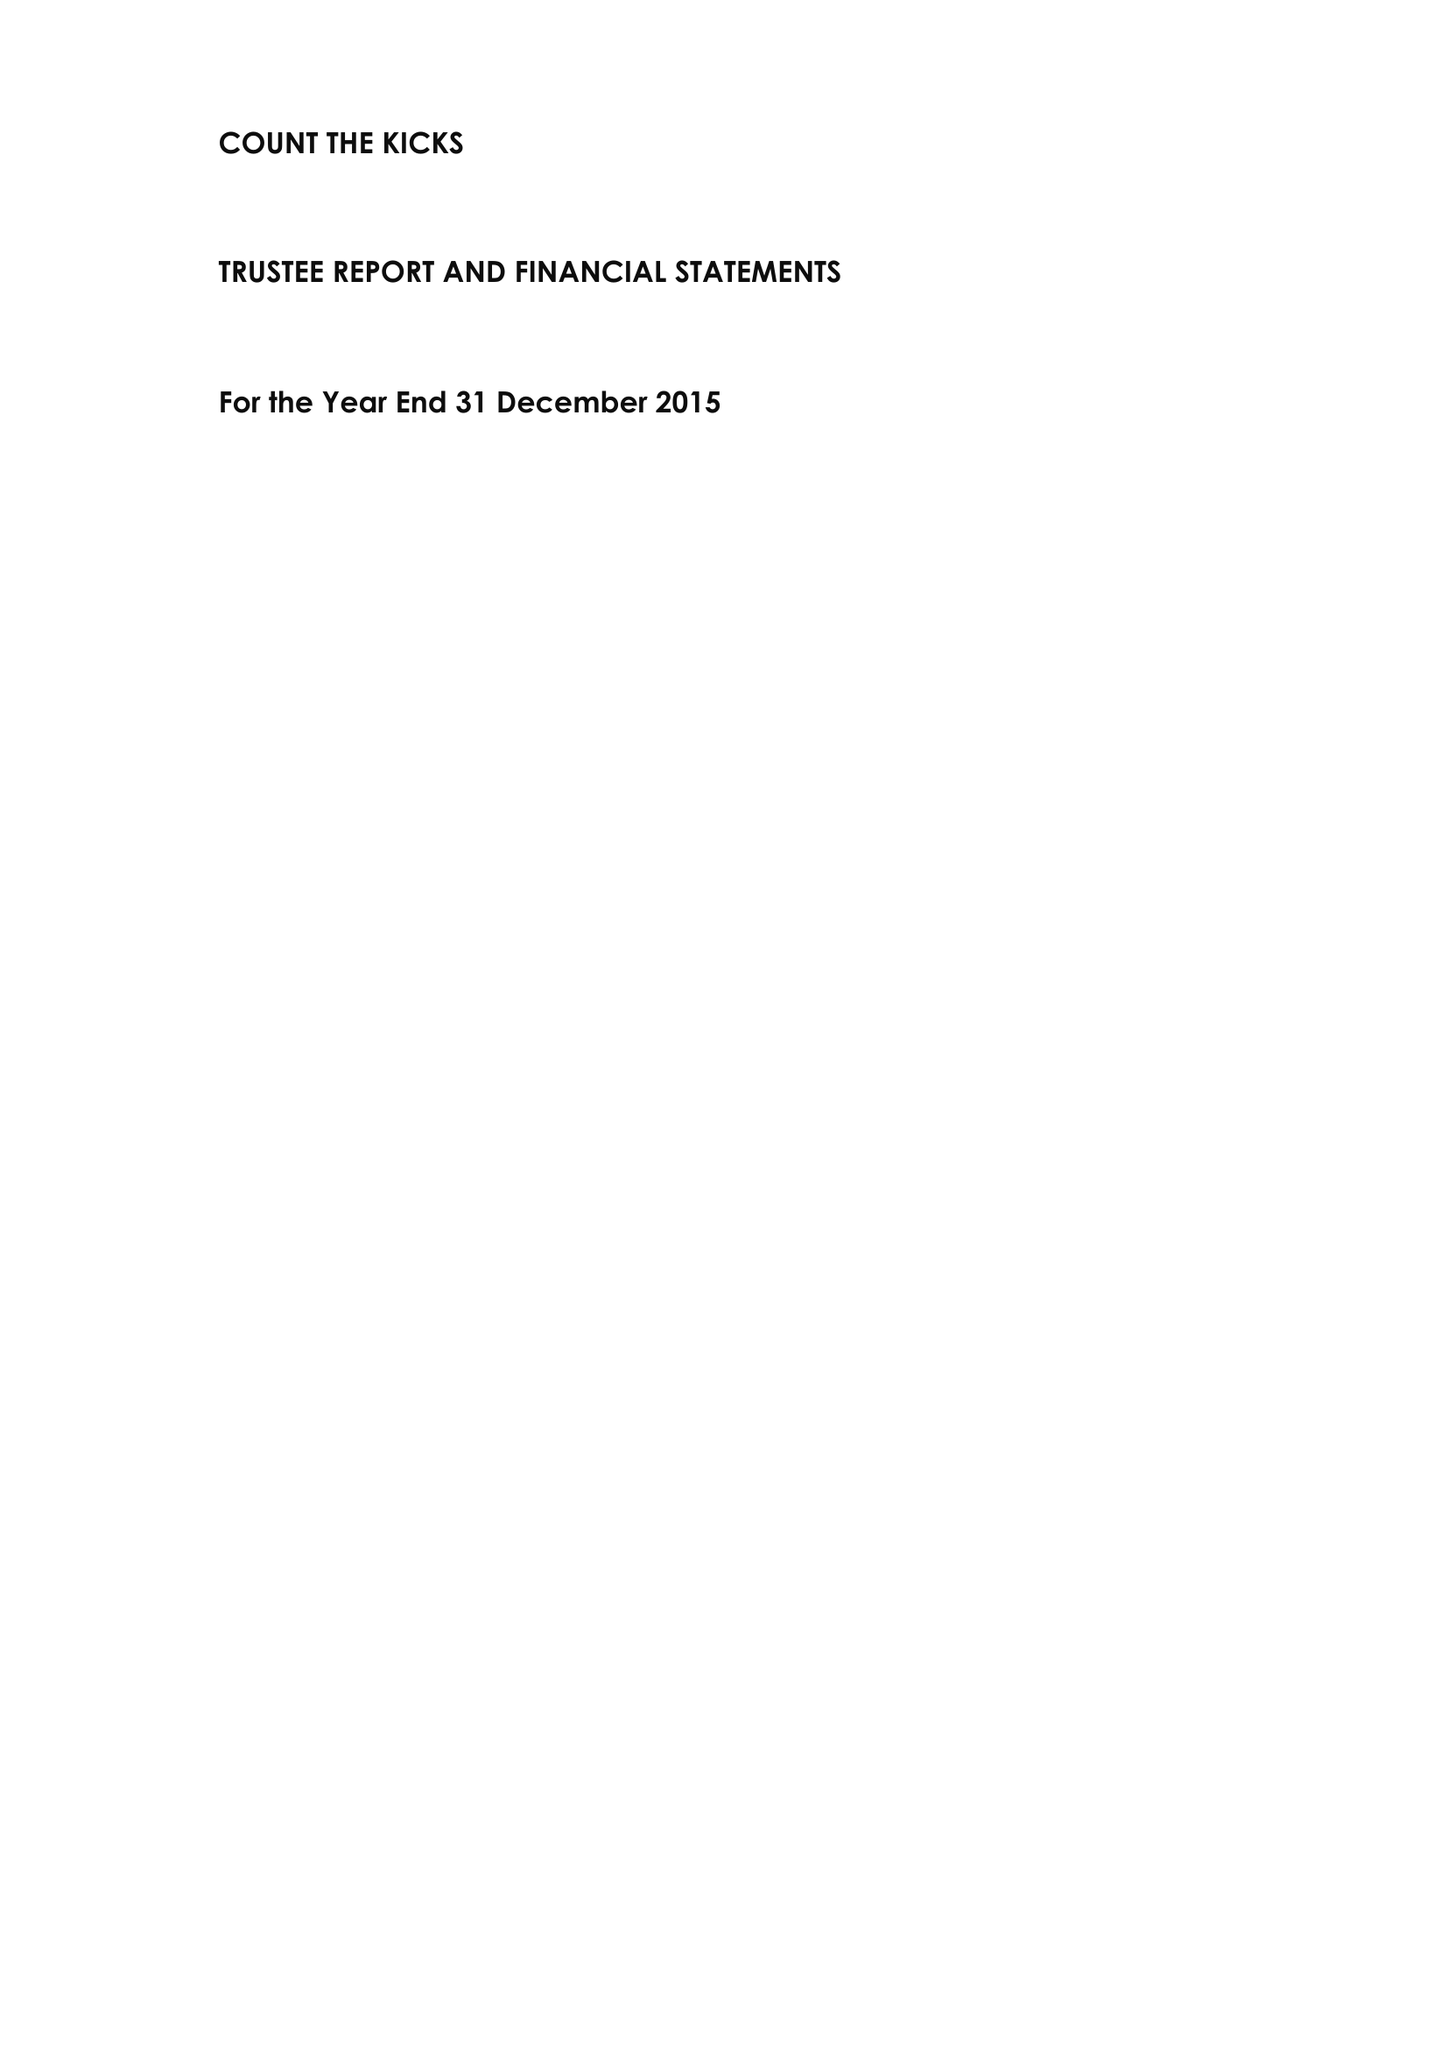What is the value for the address__post_town?
Answer the question using a single word or phrase. WOKING 